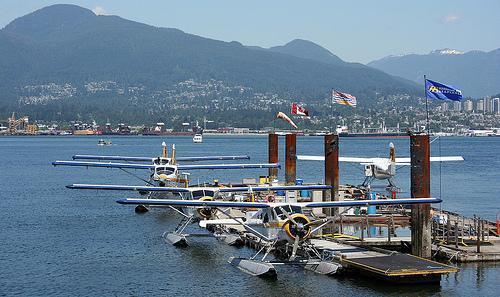How many airplanes are there?
Give a very brief answer. 5. How many planes are on the left side of the dock?
Give a very brief answer. 4. How many pilings are at the dock?
Give a very brief answer. 4. How many flags are waving?
Give a very brief answer. 4. 